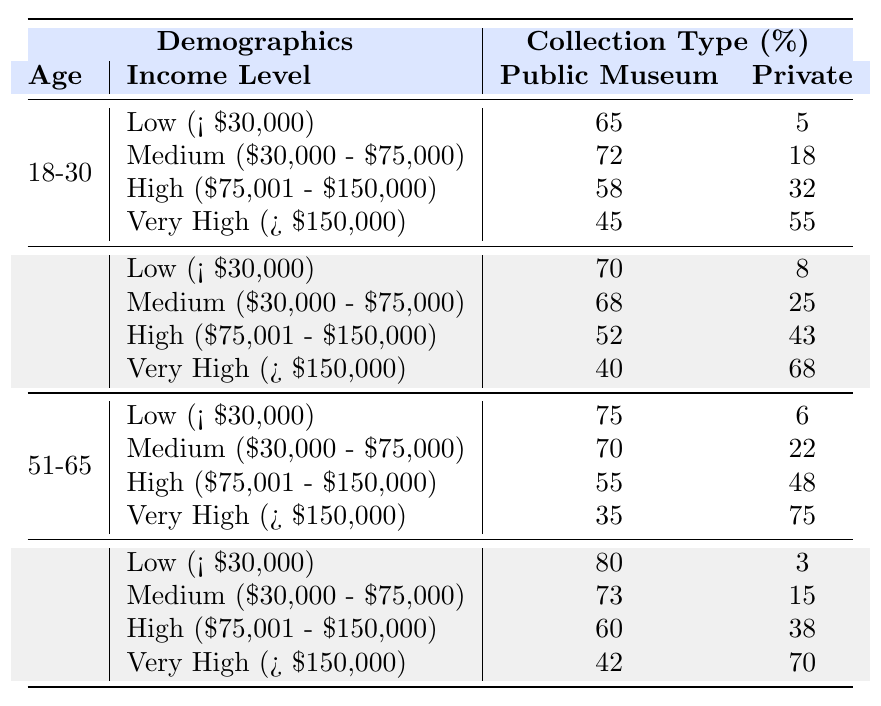What percentage of 18-30-year-olds with a "Very High" income level have a public museum collection? In the "18-30" age group, for the "Very High" income level, the table shows a percentage of 45% who have a public museum collection.
Answer: 45% Which income level has the highest percentage of private collection ownership in the 31-50 age group? In the "31-50" age group, the "Very High" income level has the highest percentage of private collection ownership at 68%.
Answer: Very High What is the overall trend in public versus private collection ownership among the 66+ age group? Analyzing the 66+ age group, public collection ownership is higher in the lower income levels, but private collection ownership surpasses public in the "Very High" income level. This shows a shift towards private collections as income increases.
Answer: Public collections decrease; private increase with higher income If we consider all age groups, what is the total percentage of public museum collection ownership? To find this, we sum the public collection percentages across all income levels and age groups: (65+72+58+45) + (70+68+52+40) + (75+70+55+35) + (80+73+60+42) = 730%, and then divide by the number of records (16) to find the average percentage which equals 45.625%.
Answer: 45.625% Is it true that more people in the 51-65 age group prefer private collections over public collections at the "High" income level? In the "51-65" age group, for the "High" income level, 55% have public collections while 48% prefer private collections. Therefore, it is false that more prefer private collections.
Answer: No What is the difference in percentage of public museum collection ownership between the 18-30 and 51-65 age groups for the low income level? For low income (< $30,000) individuals, the 18-30 age group has 65% with public collections, while the 51-65 age group has 75%. The difference is 75% - 65% = 10%.
Answer: 10% In which age and income group is the private collection ownership percentage the highest? The highest percentage of private collection ownership is found in the 31-50 age group with a "Very High" income at 68%.
Answer: 31-50, Very High What are the public collection ownership percentages for low income across different age groups? The table shows: 18-30 (65%), 31-50 (70%), 51-65 (75%), and 66+ (80%). These percentages all increase with age.
Answer: 65%, 70%, 75%, 80% How does private collection ownership in the "High" income level compare between the 31-50 and 51-65 age groups? For the "High" income level, 31-50 has 43% private collection ownership, while 51-65 has 48%. The 51-65 age group has 5% more private collections than the 31-50 age group.
Answer: 5% difference What is the percentage of "Very High" income individuals in the 18-30 age group who own a private collection? In the 18-30 age group with "Very High" income, the private collection ownership is 55%.
Answer: 55% 